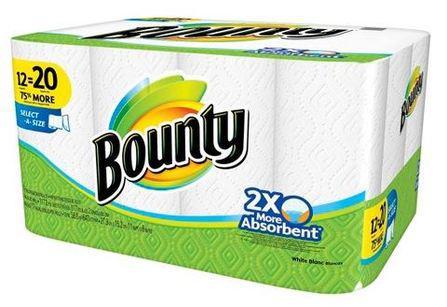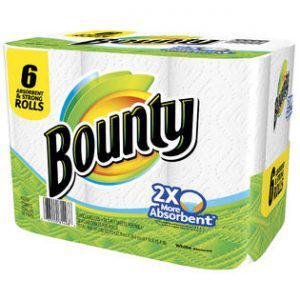The first image is the image on the left, the second image is the image on the right. Assess this claim about the two images: "There are 1 or more packages of paper towels facing right.". Correct or not? Answer yes or no. No. 